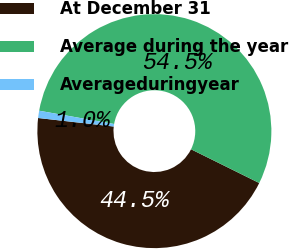<chart> <loc_0><loc_0><loc_500><loc_500><pie_chart><fcel>At December 31<fcel>Average during the year<fcel>Averageduringyear<nl><fcel>44.48%<fcel>54.52%<fcel>1.0%<nl></chart> 